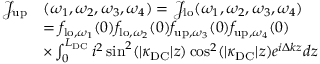<formula> <loc_0><loc_0><loc_500><loc_500>\begin{array} { r l } { \mathcal { J } _ { u p } } & { ( \omega _ { 1 } , \omega _ { 2 } , \omega _ { 3 } , \omega _ { 4 } ) = \mathcal { J } _ { l o } ( \omega _ { 1 } , \omega _ { 2 } , \omega _ { 3 } , \omega _ { 4 } ) } \\ & { = { f } _ { l o , \omega _ { 1 } } ( 0 ) { f } _ { l o , \omega _ { 2 } } ( 0 ) { f } _ { u p , \omega _ { 3 } } ( 0 ) { f } _ { u p , \omega _ { 4 } } ( 0 ) } \\ & { \times \int _ { 0 } ^ { L _ { D C } } i ^ { 2 } \sin ^ { 2 } ( | \kappa _ { D C } | z ) \cos ^ { 2 } ( | \kappa _ { D C } | z ) e ^ { i \Delta k z } d z } \end{array}</formula> 